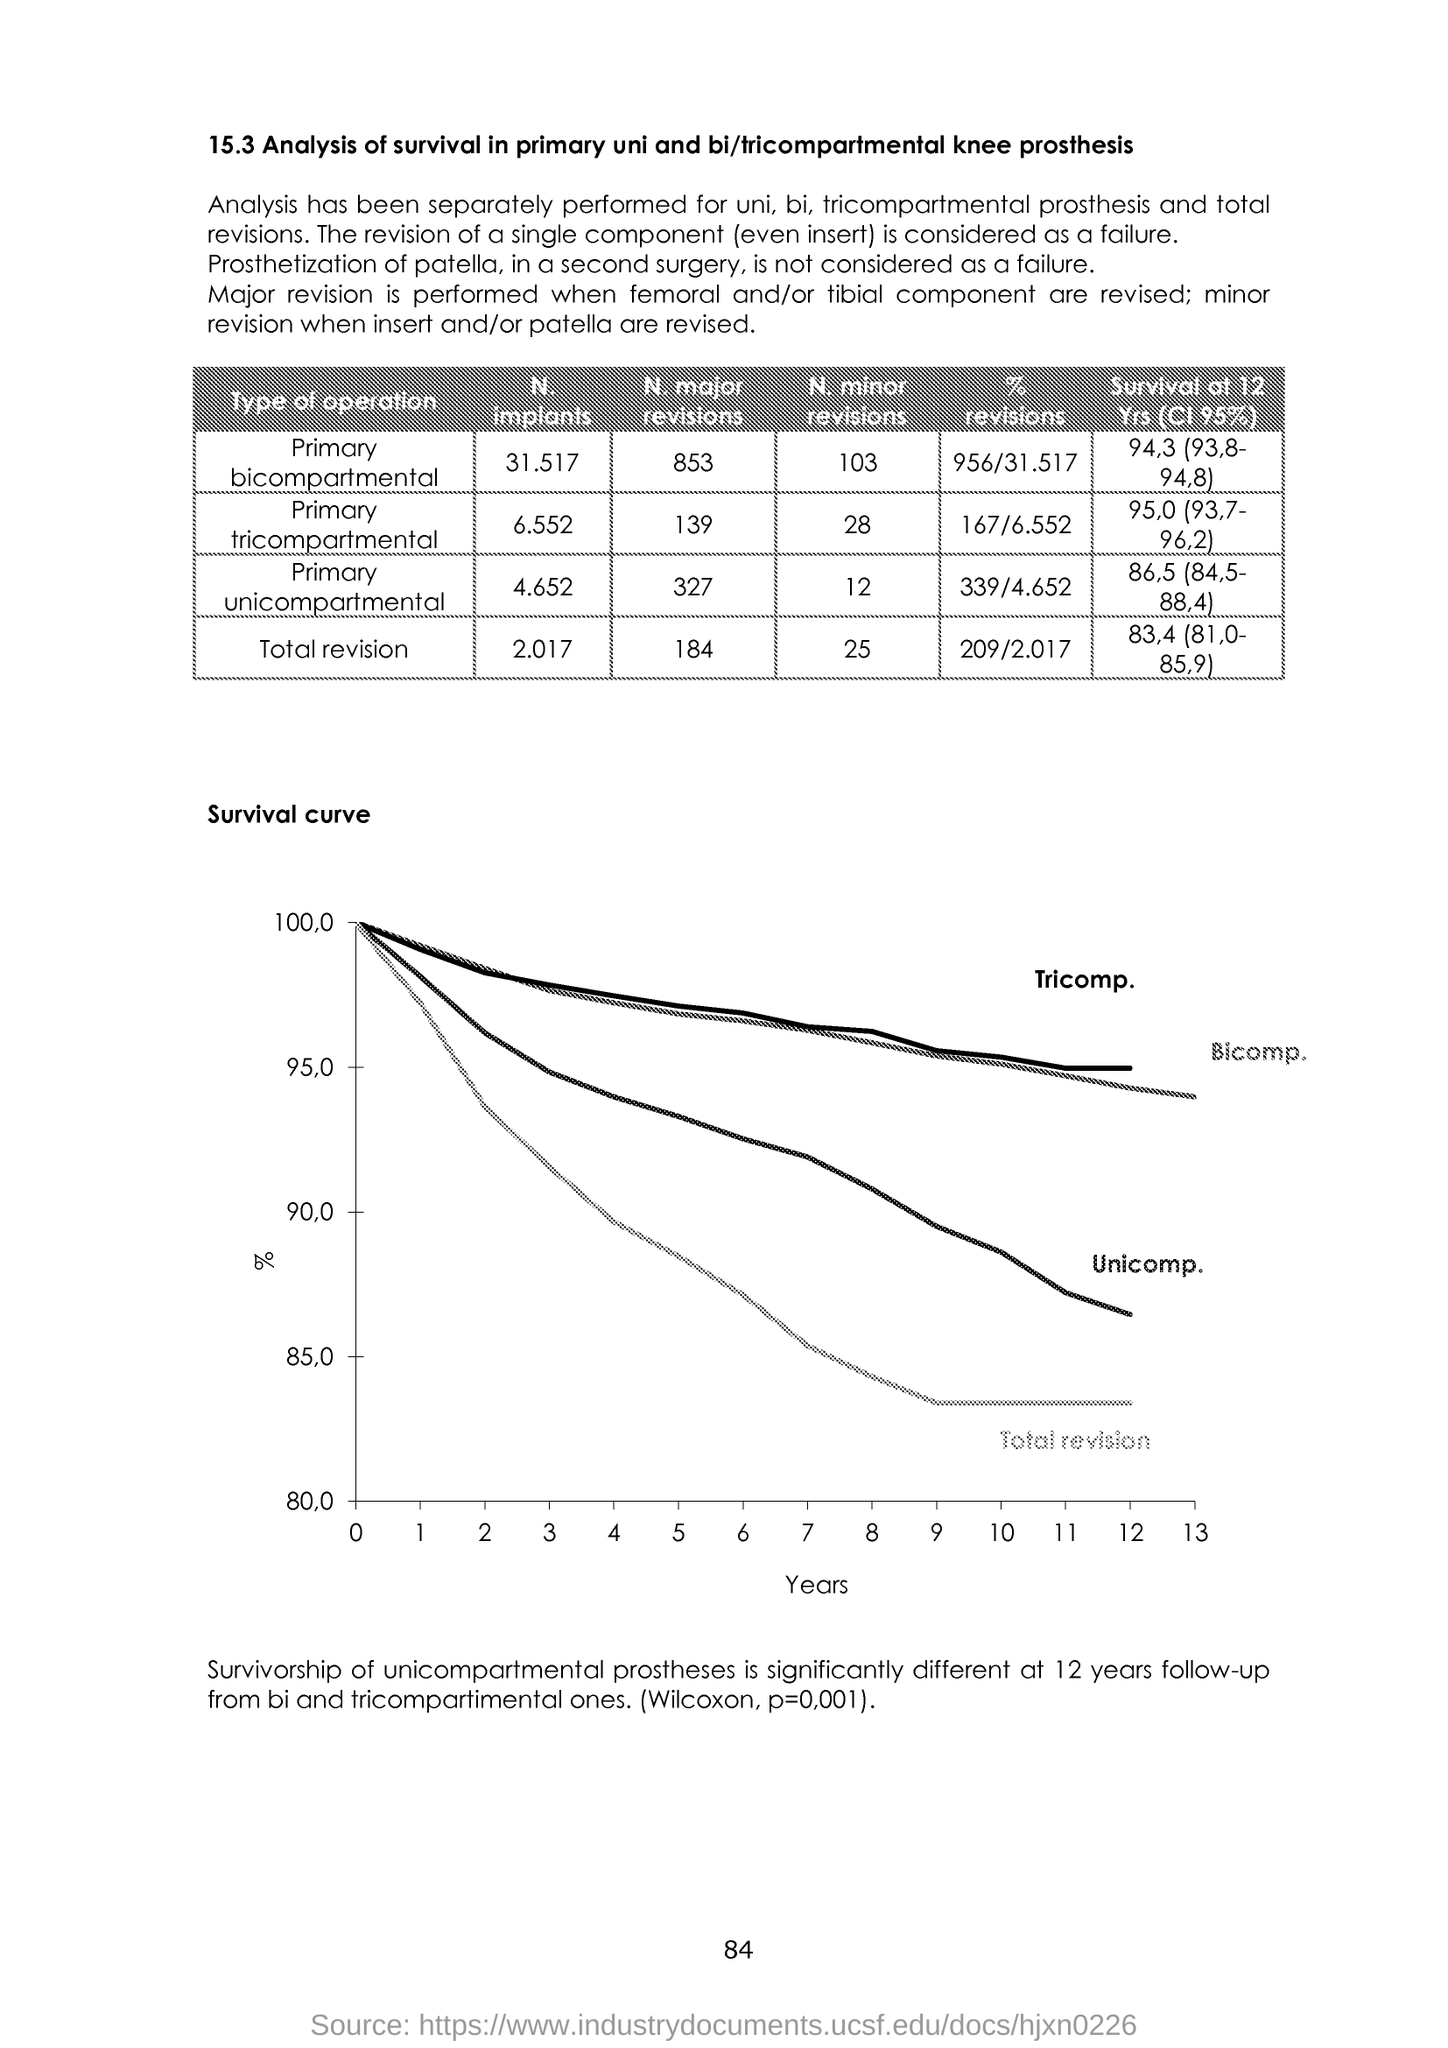Draw attention to some important aspects in this diagram. The x-axis displays the years. I am searching for page 84 of a document. 